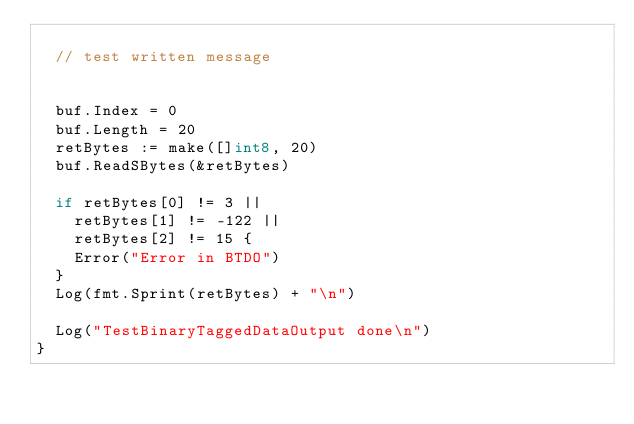Convert code to text. <code><loc_0><loc_0><loc_500><loc_500><_Go_>
	// test written message


	buf.Index = 0
	buf.Length = 20
	retBytes := make([]int8, 20)
	buf.ReadSBytes(&retBytes)

	if retBytes[0] != 3 ||
		retBytes[1] != -122 ||
		retBytes[2] != 15 {
		Error("Error in BTDO")
	}
	Log(fmt.Sprint(retBytes) + "\n")

	Log("TestBinaryTaggedDataOutput done\n")
}
</code> 